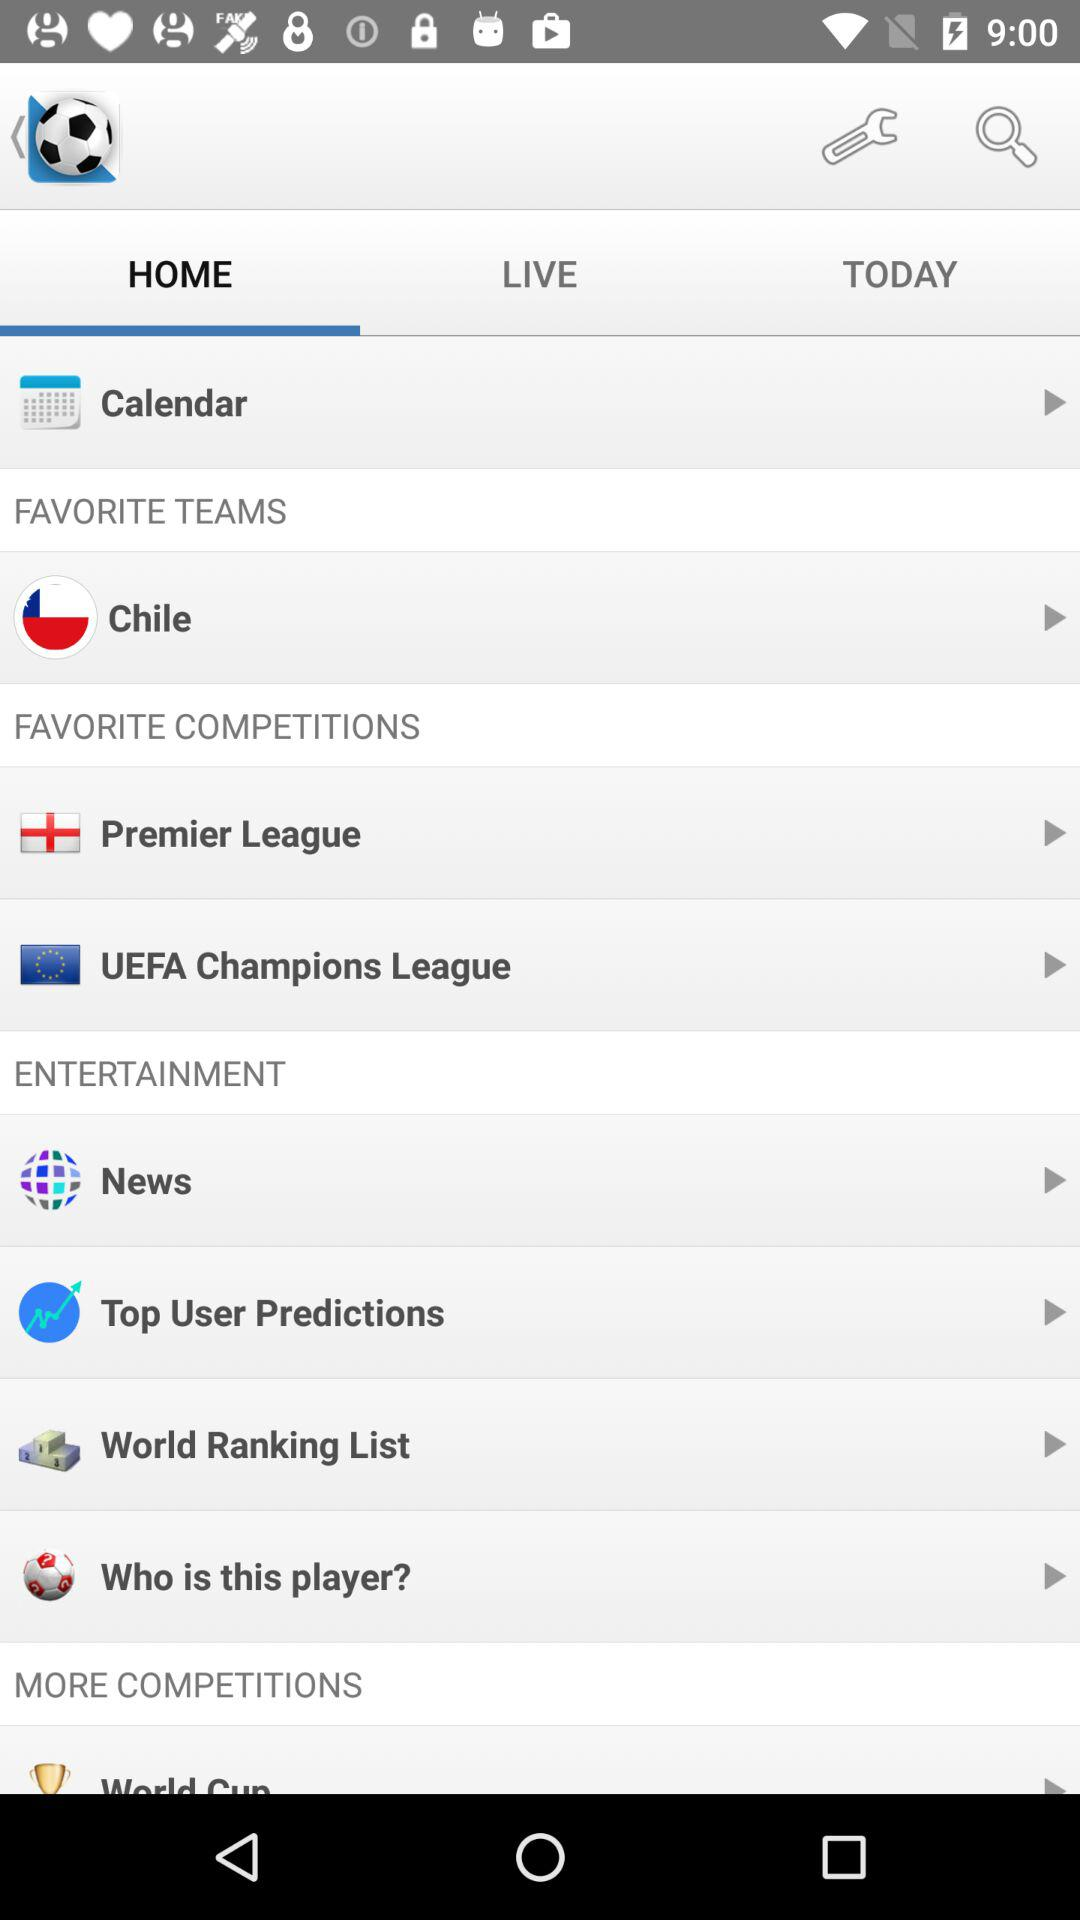What is the selected tab? The selected tab is "HOME". 